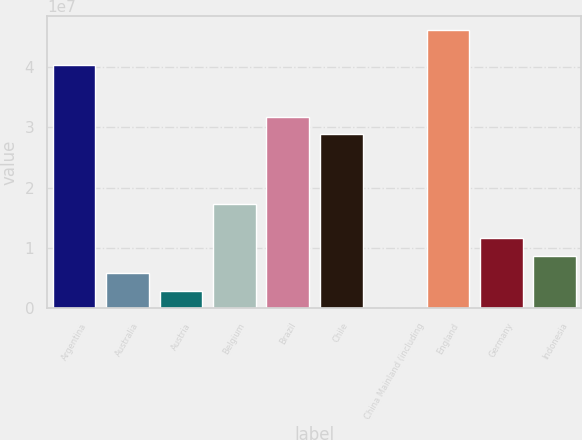<chart> <loc_0><loc_0><loc_500><loc_500><bar_chart><fcel>Argentina<fcel>Australia<fcel>Austria<fcel>Belgium<fcel>Brazil<fcel>Chile<fcel>China Mainland (including<fcel>England<fcel>Germany<fcel>Indonesia<nl><fcel>4.04303e+07<fcel>5.79335e+06<fcel>2.90693e+06<fcel>1.7339e+07<fcel>3.17711e+07<fcel>2.88847e+07<fcel>20518<fcel>4.62032e+07<fcel>1.15662e+07<fcel>8.67977e+06<nl></chart> 